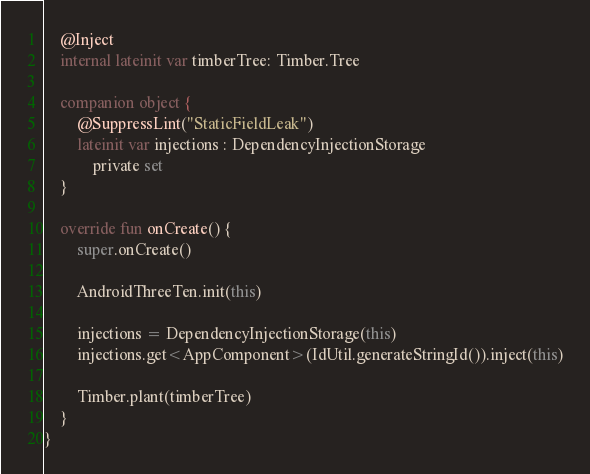Convert code to text. <code><loc_0><loc_0><loc_500><loc_500><_Kotlin_>    @Inject
    internal lateinit var timberTree: Timber.Tree

    companion object {
        @SuppressLint("StaticFieldLeak")
        lateinit var injections : DependencyInjectionStorage
            private set
    }

    override fun onCreate() {
        super.onCreate()

        AndroidThreeTen.init(this)

        injections = DependencyInjectionStorage(this)
        injections.get<AppComponent>(IdUtil.generateStringId()).inject(this)

        Timber.plant(timberTree)
    }
}</code> 